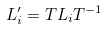Convert formula to latex. <formula><loc_0><loc_0><loc_500><loc_500>L _ { i } ^ { \prime } = T L _ { i } T ^ { - 1 }</formula> 